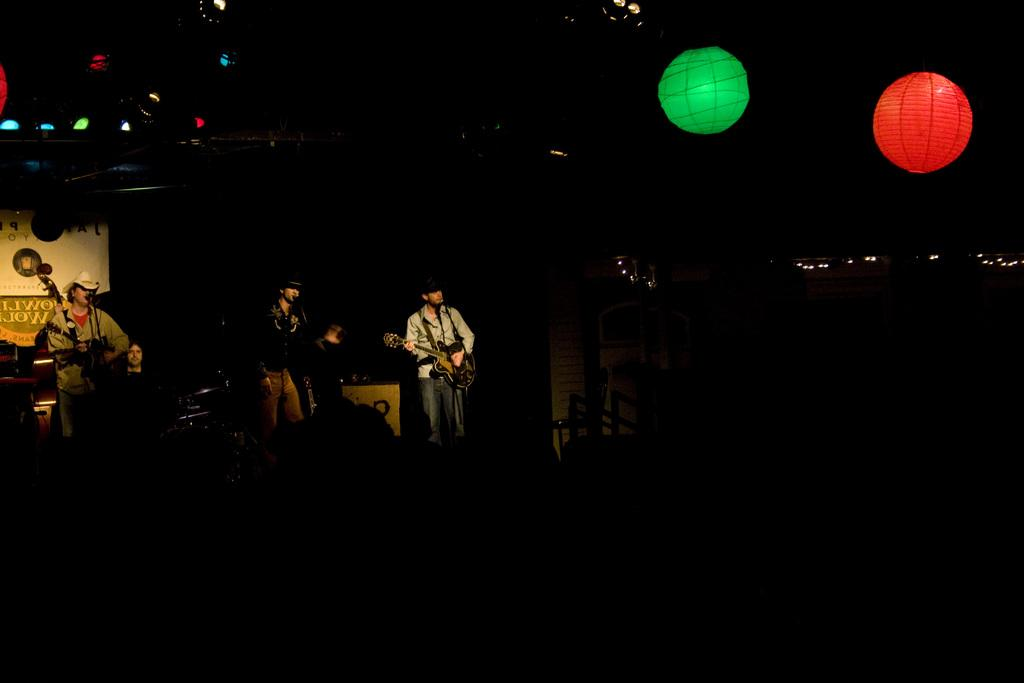How many people are in the image? There are three persons in the image. What are the persons doing in the image? The persons are playing guitars. What other objects can be seen in the image besides the guitars? There are decorative balls, lights, and a banner in the image. What is the color of the background in the image? The background of the image is dark. What type of bird is perched on the banner in the image? There is no bird present in the image; it only features three persons playing guitars, decorative balls, lights, and a banner. What color is the wool used to make the banner in the image? There is no wool mentioned or visible in the image; the banner's material is not specified. 